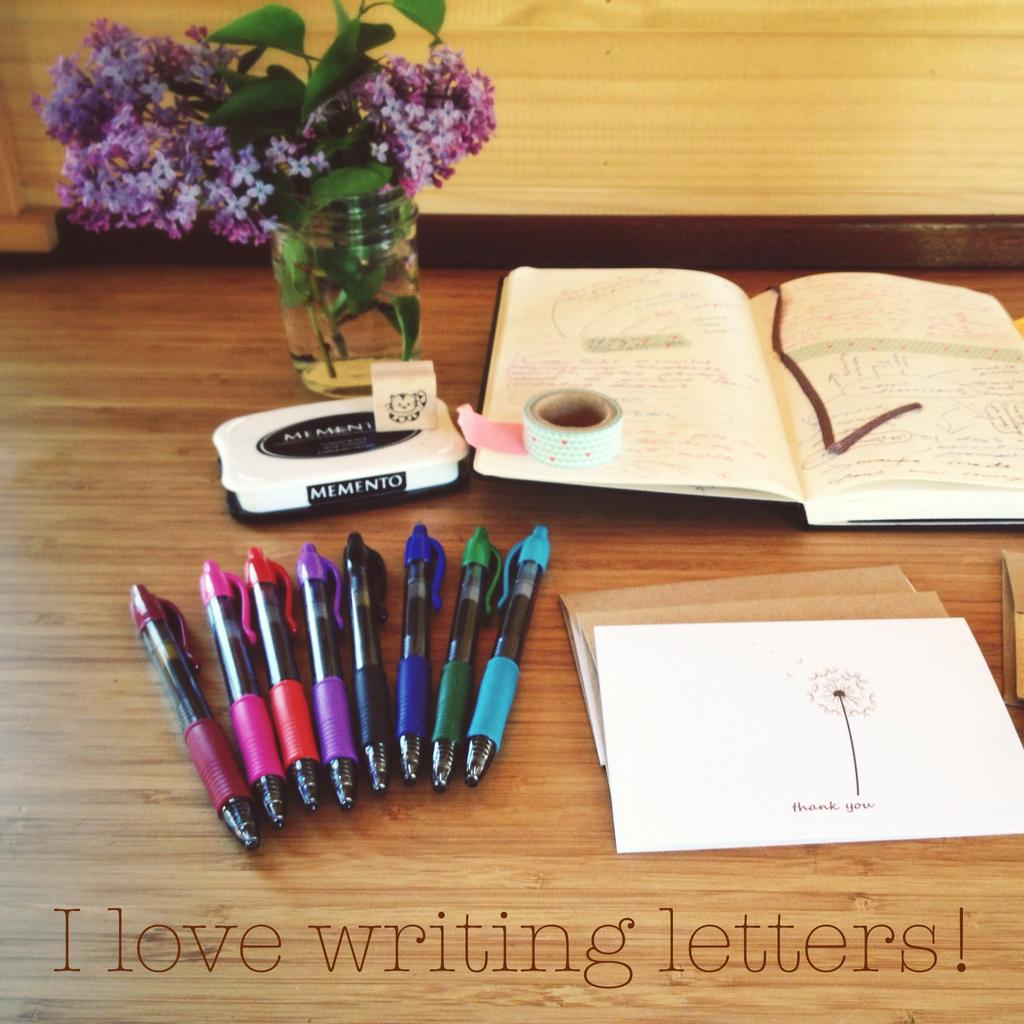What type of writing instruments are in the image? There are multi-color pens in the image. What else can be seen on the table besides the pens? There are papers and a book in the image. What is the color of the table in the image? The table is brown. What type of flowers are in the flower pot? The flowers in the flower pot are purple. What type of beast can be seen arguing with the pens in the image? There is no beast present in the image, nor is there any argument taking place. 